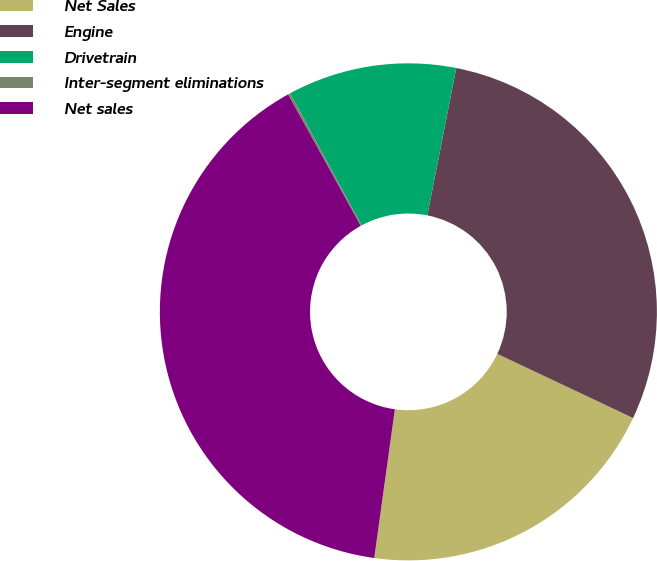Convert chart to OTSL. <chart><loc_0><loc_0><loc_500><loc_500><pie_chart><fcel>Net Sales<fcel>Engine<fcel>Drivetrain<fcel>Inter-segment eliminations<fcel>Net sales<nl><fcel>20.17%<fcel>28.94%<fcel>10.98%<fcel>0.15%<fcel>39.77%<nl></chart> 